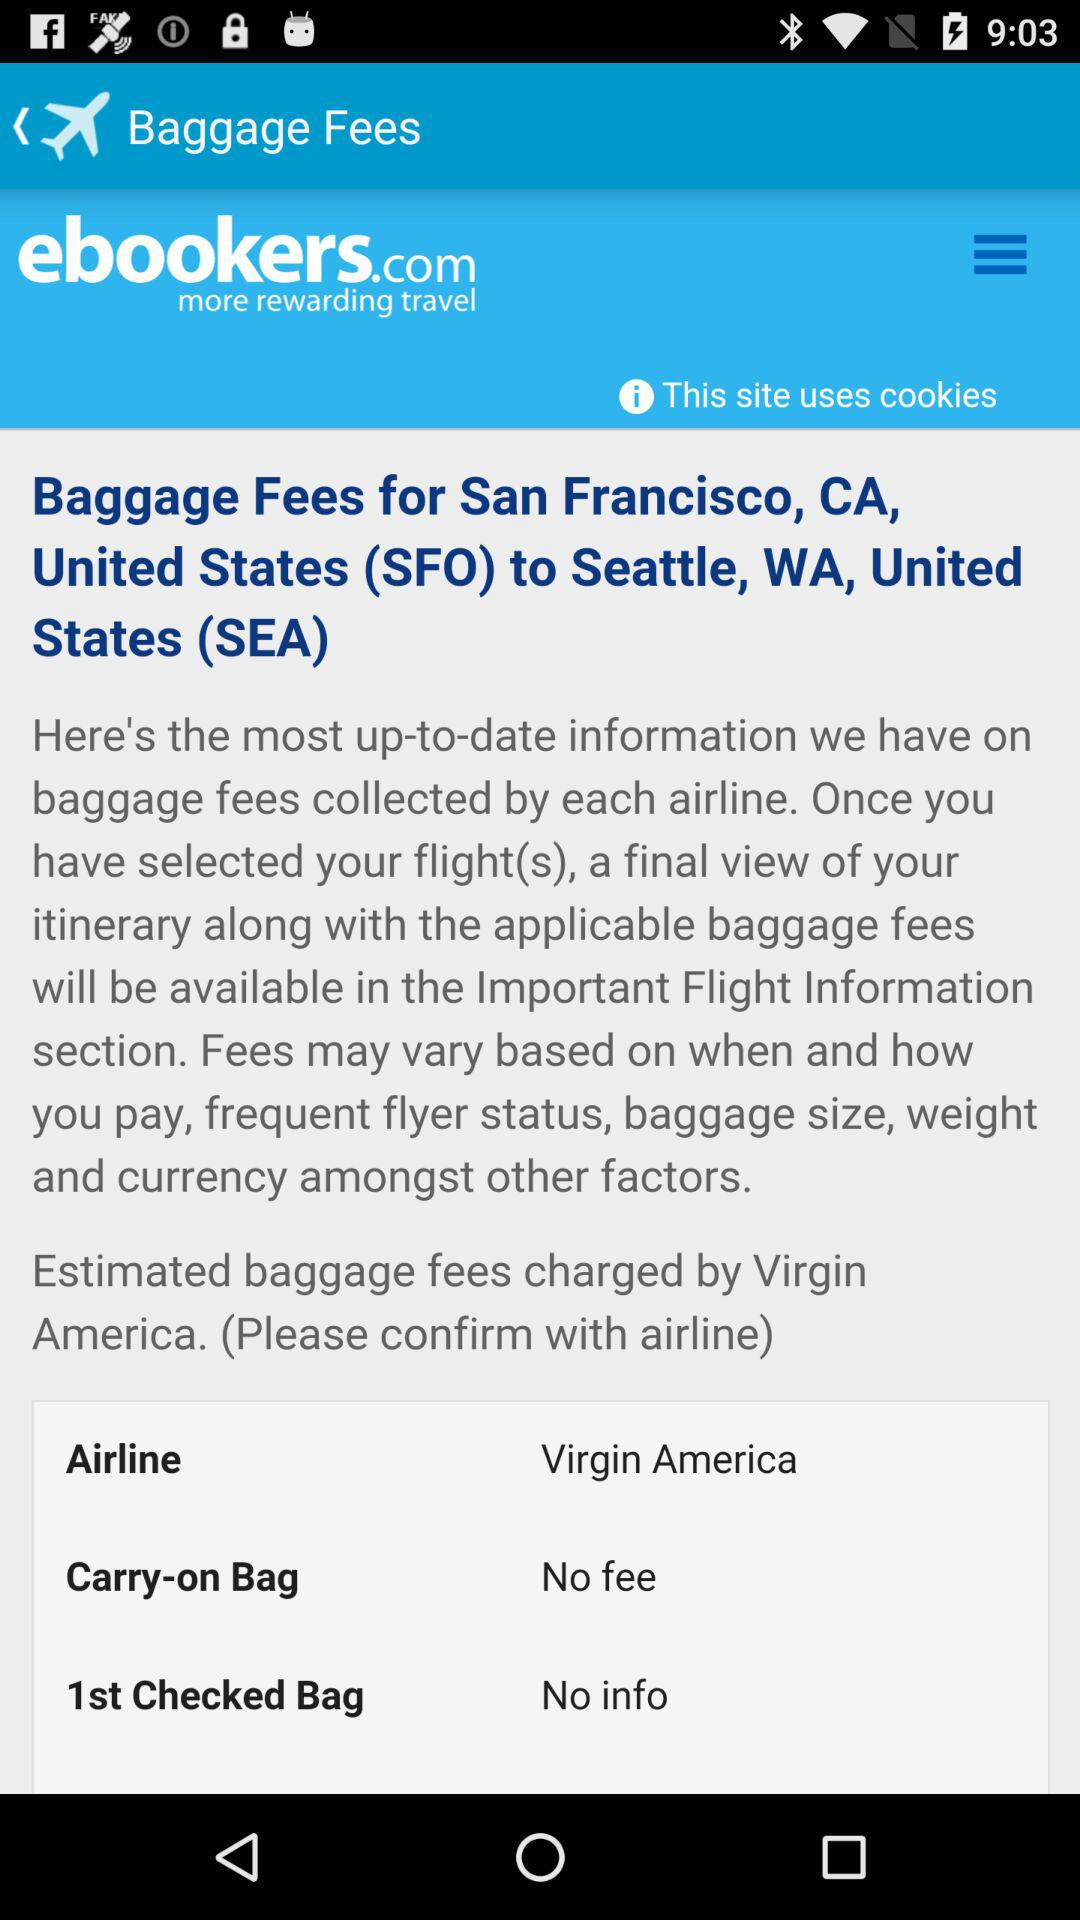What is the information about the 1st checked bag? There is no information about the 1st checked bag. 